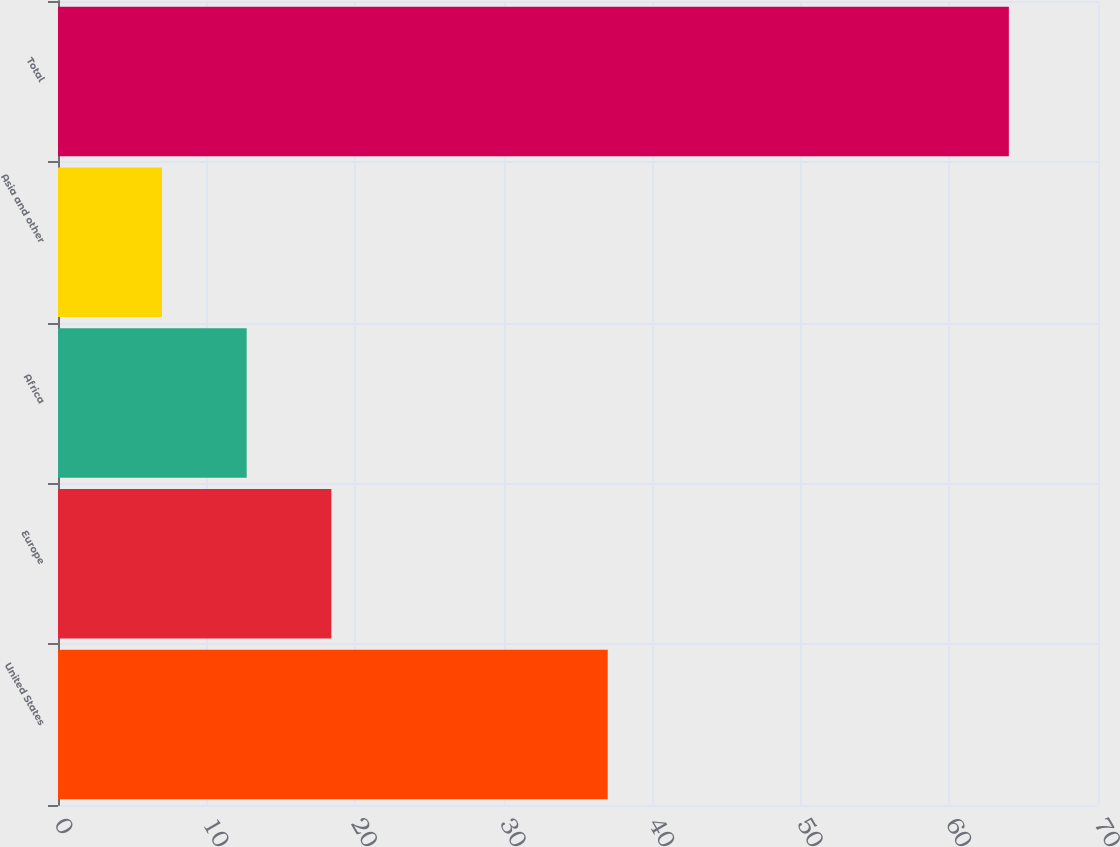<chart> <loc_0><loc_0><loc_500><loc_500><bar_chart><fcel>United States<fcel>Europe<fcel>Africa<fcel>Asia and other<fcel>Total<nl><fcel>37<fcel>18.4<fcel>12.7<fcel>7<fcel>64<nl></chart> 